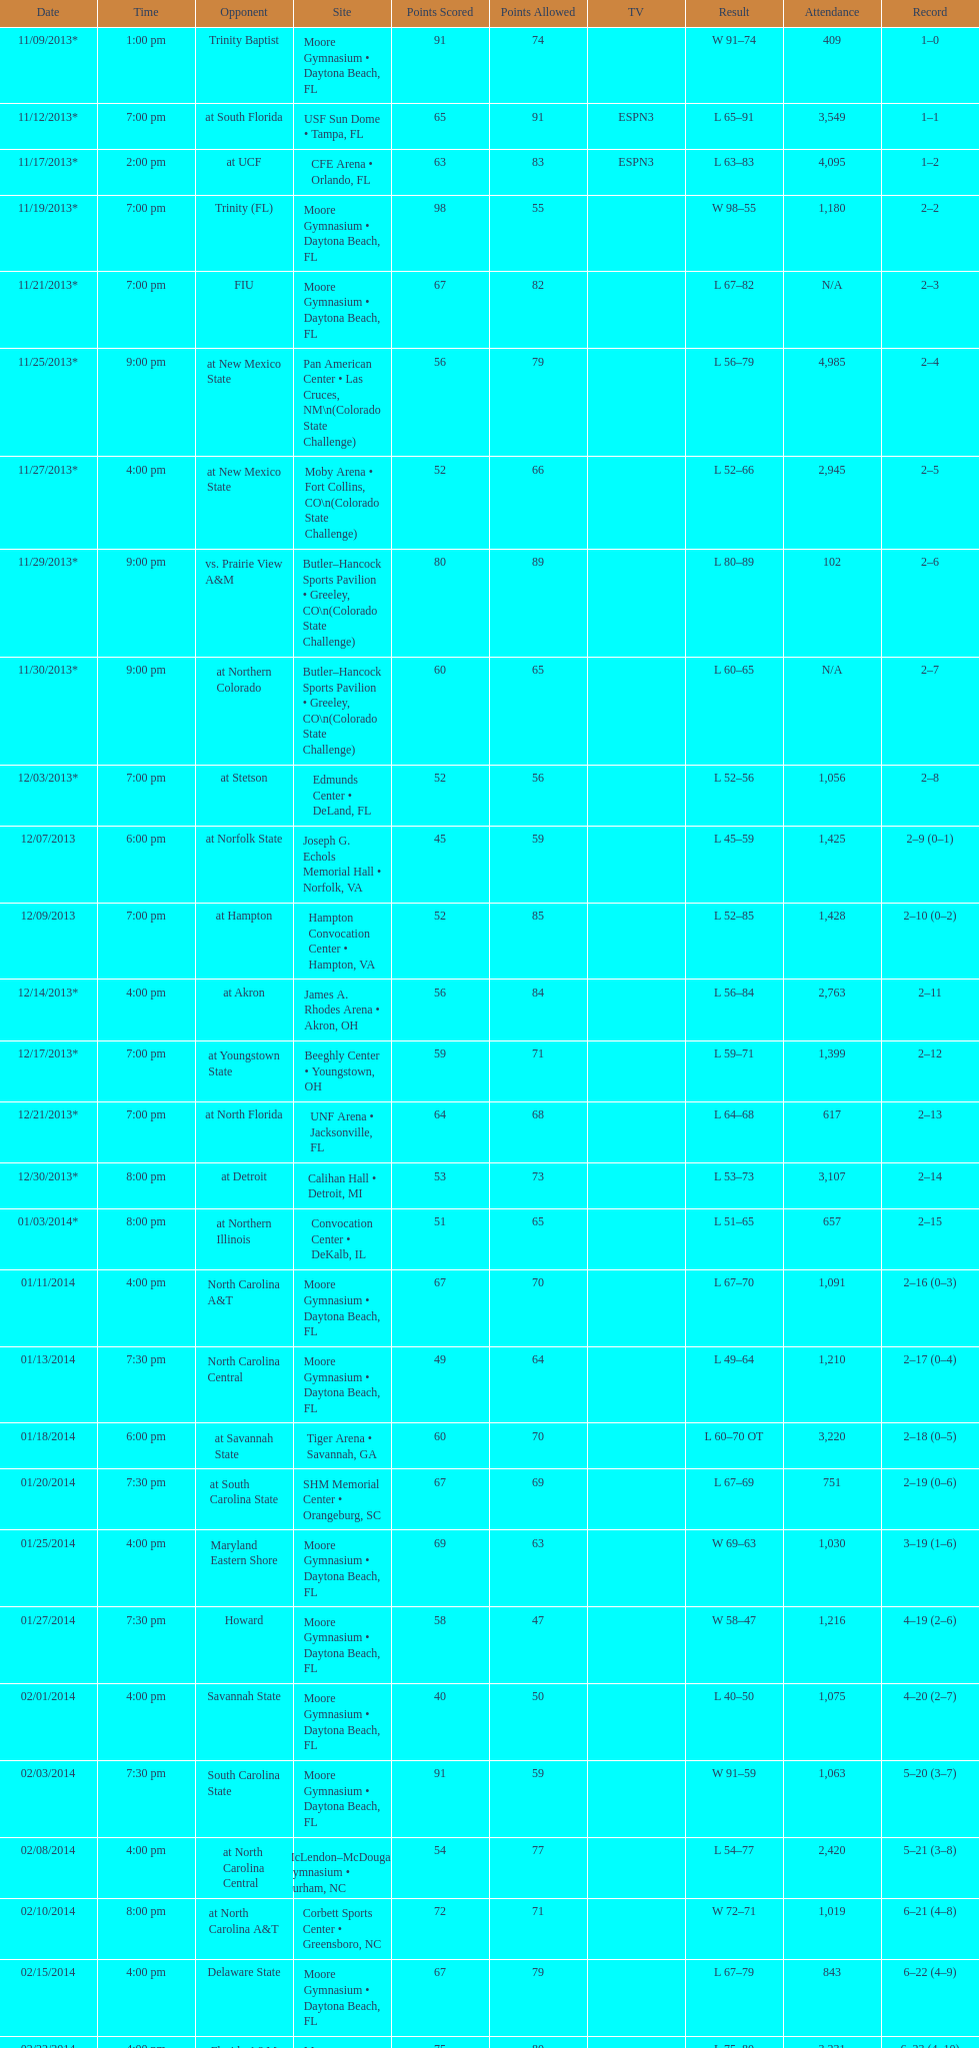Which game was won by a bigger margin, against trinity (fl) or against trinity baptist? Trinity (FL). 